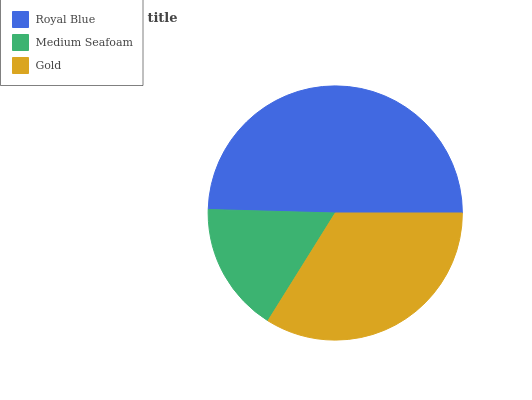Is Medium Seafoam the minimum?
Answer yes or no. Yes. Is Royal Blue the maximum?
Answer yes or no. Yes. Is Gold the minimum?
Answer yes or no. No. Is Gold the maximum?
Answer yes or no. No. Is Gold greater than Medium Seafoam?
Answer yes or no. Yes. Is Medium Seafoam less than Gold?
Answer yes or no. Yes. Is Medium Seafoam greater than Gold?
Answer yes or no. No. Is Gold less than Medium Seafoam?
Answer yes or no. No. Is Gold the high median?
Answer yes or no. Yes. Is Gold the low median?
Answer yes or no. Yes. Is Royal Blue the high median?
Answer yes or no. No. Is Royal Blue the low median?
Answer yes or no. No. 